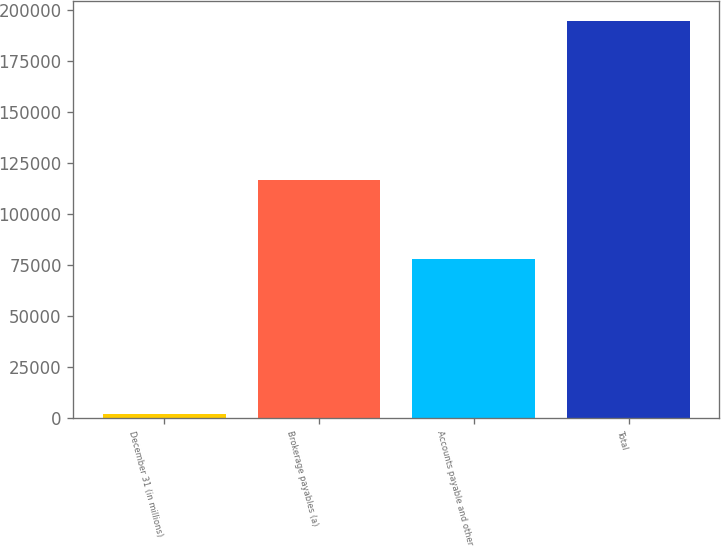Convert chart. <chart><loc_0><loc_0><loc_500><loc_500><bar_chart><fcel>December 31 (in millions)<fcel>Brokerage payables (a)<fcel>Accounts payable and other<fcel>Total<nl><fcel>2013<fcel>116391<fcel>78100<fcel>194491<nl></chart> 